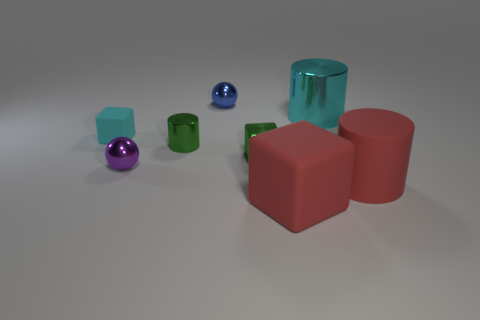How many large cyan cylinders are there?
Ensure brevity in your answer.  1. What number of objects are in front of the big cyan shiny cylinder and behind the red cylinder?
Your response must be concise. 4. Are there any tiny blue balls made of the same material as the green cube?
Your response must be concise. Yes. There is a tiny thing behind the cyan object to the right of the purple metal sphere; what is it made of?
Your response must be concise. Metal. Are there an equal number of cyan objects on the left side of the blue shiny object and big things that are right of the large cyan thing?
Give a very brief answer. Yes. Does the cyan shiny thing have the same shape as the blue thing?
Make the answer very short. No. There is a cylinder that is both in front of the big cyan metal cylinder and left of the large red cylinder; what is it made of?
Your answer should be compact. Metal. How many large rubber things are the same shape as the blue metallic object?
Your answer should be very brief. 0. What size is the ball that is in front of the green object that is right of the thing behind the cyan metallic thing?
Give a very brief answer. Small. Are there more metallic things on the right side of the big matte block than tiny yellow cubes?
Provide a short and direct response. Yes. 